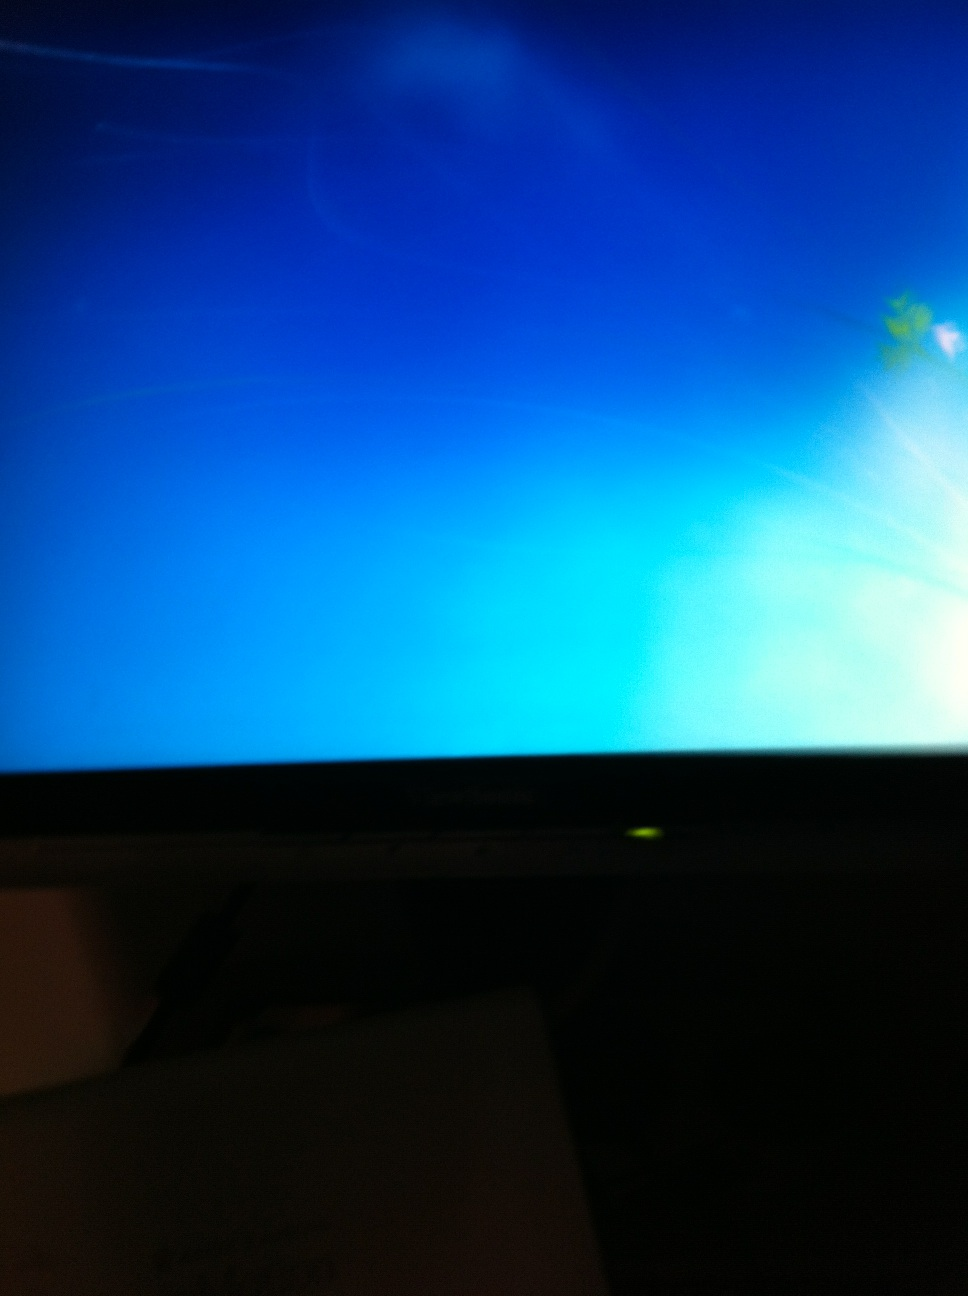Looking for any error messages on the screen? My computer doesn't want to boot up and I don't know what the error message is. I turned off the light. Maybe that will help. Thank you. I'm sorry, but the image is too blurry to discern any specific error messages or details from the screen. Generally, if your computer is failing to boot up, you can try checking the connections, performing a hard reboot, booting into safe mode, or using a recovery drive. If possible, try to capture a clear and well-lit photo of the screen for more precise assistance. 